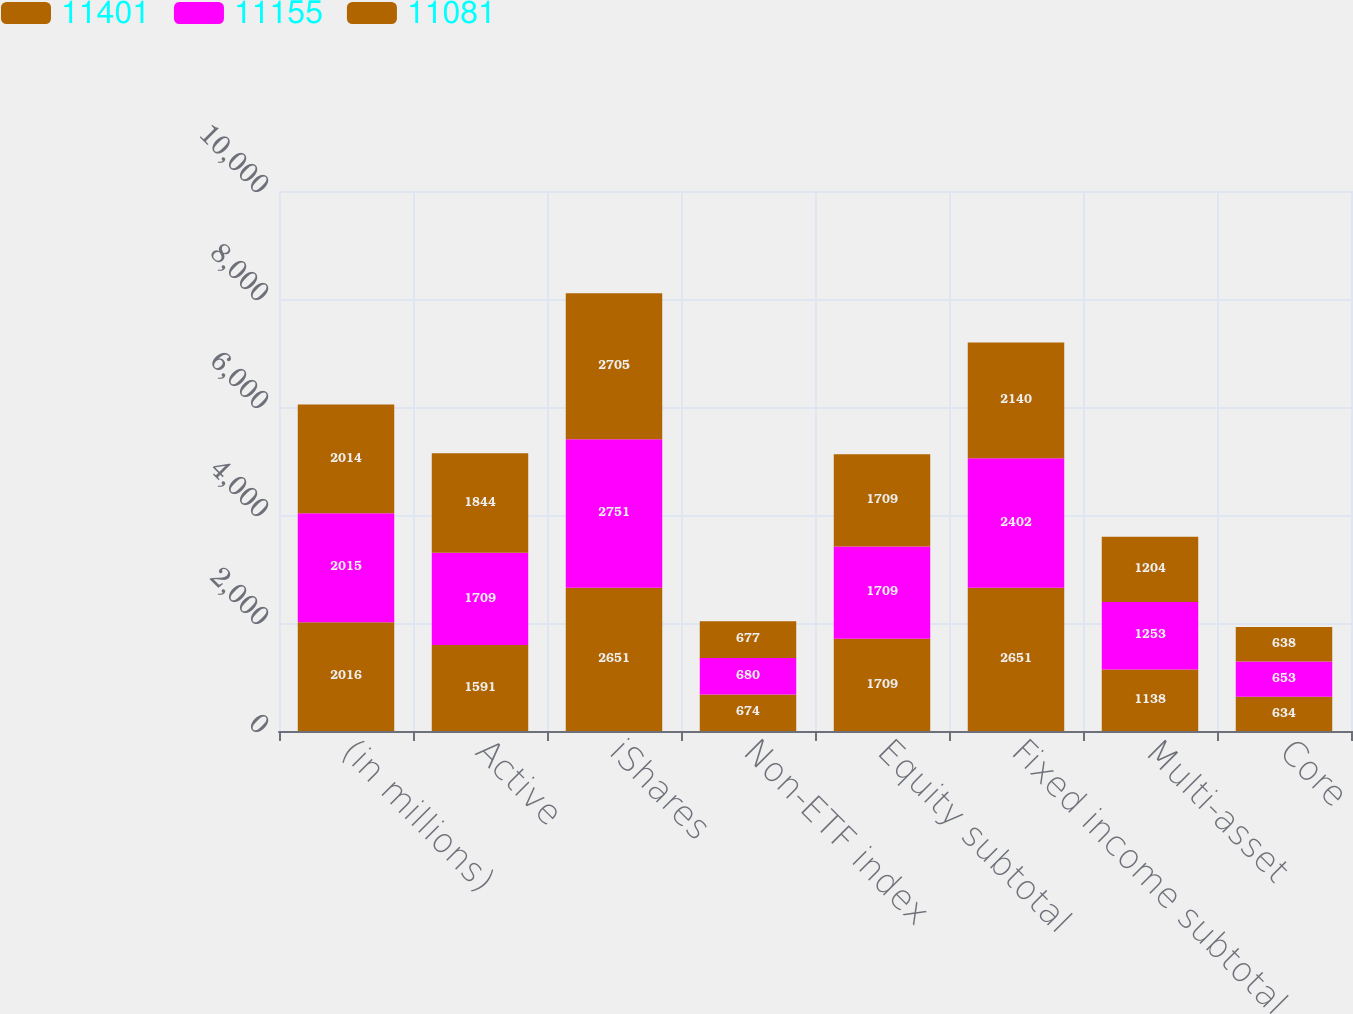<chart> <loc_0><loc_0><loc_500><loc_500><stacked_bar_chart><ecel><fcel>(in millions)<fcel>Active<fcel>iShares<fcel>Non-ETF index<fcel>Equity subtotal<fcel>Fixed income subtotal<fcel>Multi-asset<fcel>Core<nl><fcel>11401<fcel>2016<fcel>1591<fcel>2651<fcel>674<fcel>1709<fcel>2651<fcel>1138<fcel>634<nl><fcel>11155<fcel>2015<fcel>1709<fcel>2751<fcel>680<fcel>1709<fcel>2402<fcel>1253<fcel>653<nl><fcel>11081<fcel>2014<fcel>1844<fcel>2705<fcel>677<fcel>1709<fcel>2140<fcel>1204<fcel>638<nl></chart> 